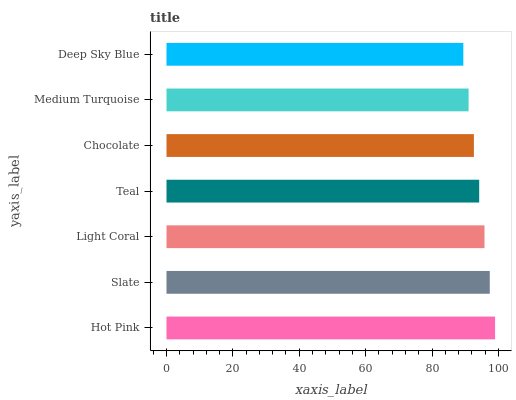Is Deep Sky Blue the minimum?
Answer yes or no. Yes. Is Hot Pink the maximum?
Answer yes or no. Yes. Is Slate the minimum?
Answer yes or no. No. Is Slate the maximum?
Answer yes or no. No. Is Hot Pink greater than Slate?
Answer yes or no. Yes. Is Slate less than Hot Pink?
Answer yes or no. Yes. Is Slate greater than Hot Pink?
Answer yes or no. No. Is Hot Pink less than Slate?
Answer yes or no. No. Is Teal the high median?
Answer yes or no. Yes. Is Teal the low median?
Answer yes or no. Yes. Is Medium Turquoise the high median?
Answer yes or no. No. Is Slate the low median?
Answer yes or no. No. 